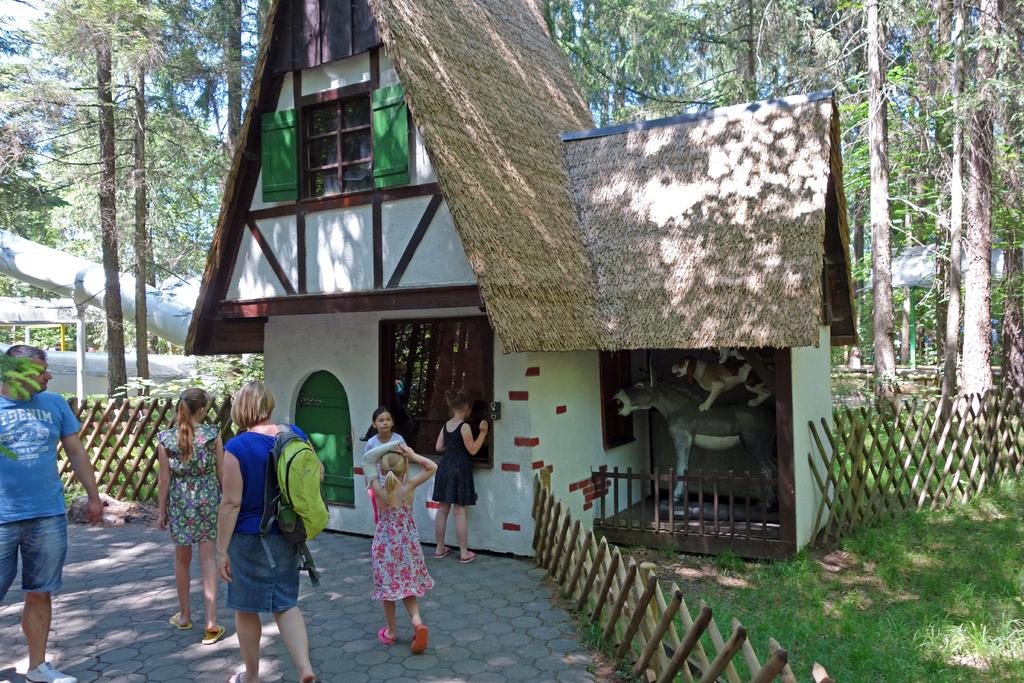What can be seen on the ground in the image? There are people on the ground in the image. What type of barrier is present in the image? There is a fence in the image. What type of building is visible in the image? There is a house in the image. What type of artwork is present in the image? There is a statue of animals in the image. What type of vegetation is visible in the background of the image? There are trees in the background of the image. What type of structure is visible in the background of the image? There is a shed in the background of the image. What part of the natural environment is visible in the background of the image? The sky is visible in the background of the image. What other unspecified objects can be seen in the background of the image? There are some unspecified objects in the background of the image. What type of ear is visible on the statue of animals in the image? There is no ear visible on the statue of animals in the image. What type of fang can be seen in the background of the image? There are no fangs present in the image. What type of paste is being used by the people on the ground in the image? There is no paste visible in the image. 